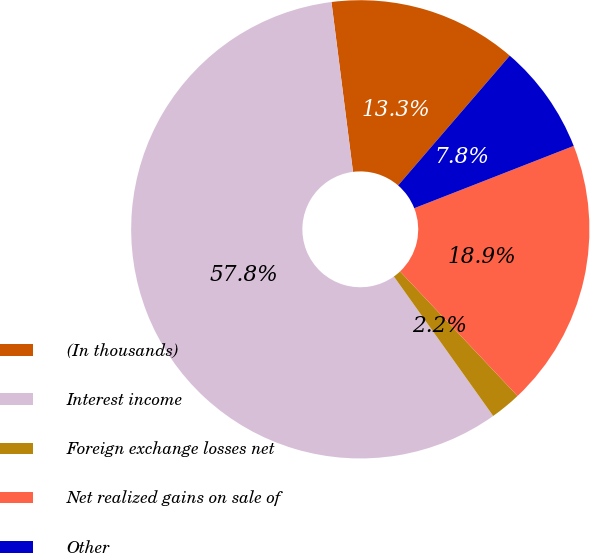Convert chart. <chart><loc_0><loc_0><loc_500><loc_500><pie_chart><fcel>(In thousands)<fcel>Interest income<fcel>Foreign exchange losses net<fcel>Net realized gains on sale of<fcel>Other<nl><fcel>13.32%<fcel>57.84%<fcel>2.19%<fcel>18.89%<fcel>7.76%<nl></chart> 